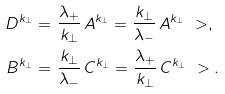Convert formula to latex. <formula><loc_0><loc_0><loc_500><loc_500>D ^ { k _ { \perp } } = & \ \frac { \lambda _ { + } } { k _ { \perp } } \, A ^ { k _ { \perp } } = \frac { k _ { \perp } } { \lambda _ { - } } \, A ^ { k _ { \perp } } \ > , \\ B ^ { k _ { \perp } } = & \ \frac { k _ { \perp } } { \lambda _ { - } } \, C ^ { k _ { \perp } } = \frac { \lambda _ { + } } { k _ { \perp } } \, C ^ { k _ { \perp } } \ > .</formula> 